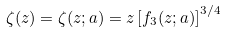<formula> <loc_0><loc_0><loc_500><loc_500>\zeta ( z ) = \zeta ( z ; a ) = z \left [ f _ { 3 } ( z ; a ) \right ] ^ { 3 / 4 }</formula> 